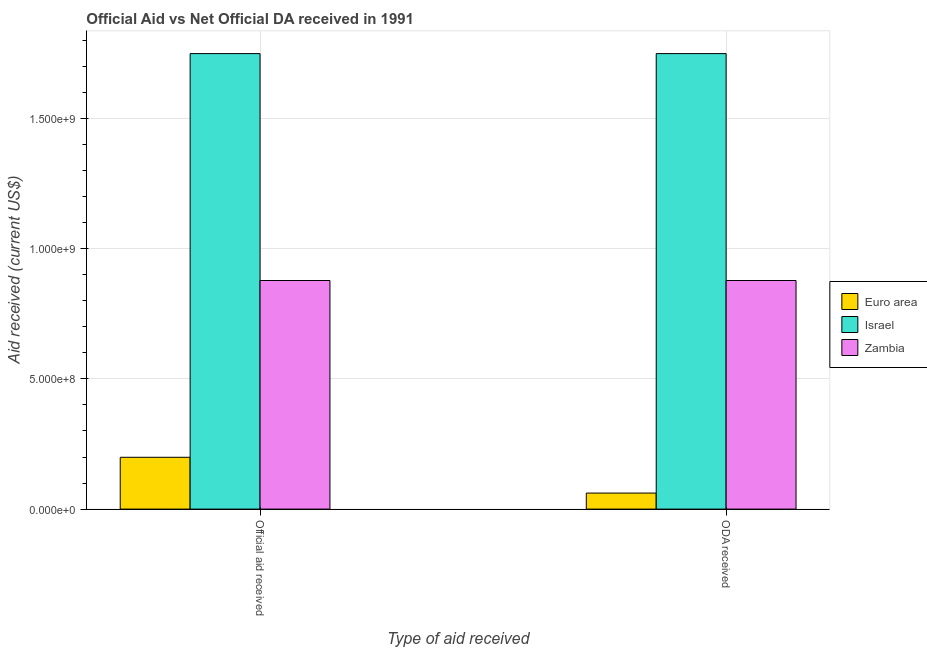How many different coloured bars are there?
Ensure brevity in your answer.  3. How many bars are there on the 1st tick from the right?
Make the answer very short. 3. What is the label of the 2nd group of bars from the left?
Provide a short and direct response. ODA received. What is the oda received in Euro area?
Offer a very short reply. 6.16e+07. Across all countries, what is the maximum official aid received?
Offer a terse response. 1.75e+09. Across all countries, what is the minimum official aid received?
Keep it short and to the point. 1.99e+08. In which country was the official aid received minimum?
Provide a short and direct response. Euro area. What is the total official aid received in the graph?
Keep it short and to the point. 2.83e+09. What is the difference between the official aid received in Euro area and that in Zambia?
Your response must be concise. -6.79e+08. What is the difference between the official aid received in Zambia and the oda received in Euro area?
Offer a very short reply. 8.16e+08. What is the average official aid received per country?
Your response must be concise. 9.42e+08. What is the ratio of the official aid received in Zambia to that in Israel?
Your response must be concise. 0.5. In how many countries, is the official aid received greater than the average official aid received taken over all countries?
Make the answer very short. 1. What does the 3rd bar from the left in ODA received represents?
Keep it short and to the point. Zambia. What does the 1st bar from the right in Official aid received represents?
Provide a succinct answer. Zambia. How many countries are there in the graph?
Your answer should be very brief. 3. Are the values on the major ticks of Y-axis written in scientific E-notation?
Ensure brevity in your answer.  Yes. Does the graph contain grids?
Give a very brief answer. Yes. How are the legend labels stacked?
Your answer should be compact. Vertical. What is the title of the graph?
Your answer should be compact. Official Aid vs Net Official DA received in 1991 . What is the label or title of the X-axis?
Keep it short and to the point. Type of aid received. What is the label or title of the Y-axis?
Offer a very short reply. Aid received (current US$). What is the Aid received (current US$) in Euro area in Official aid received?
Keep it short and to the point. 1.99e+08. What is the Aid received (current US$) in Israel in Official aid received?
Offer a very short reply. 1.75e+09. What is the Aid received (current US$) in Zambia in Official aid received?
Ensure brevity in your answer.  8.78e+08. What is the Aid received (current US$) of Euro area in ODA received?
Your answer should be very brief. 6.16e+07. What is the Aid received (current US$) in Israel in ODA received?
Provide a short and direct response. 1.75e+09. What is the Aid received (current US$) of Zambia in ODA received?
Your answer should be compact. 8.78e+08. Across all Type of aid received, what is the maximum Aid received (current US$) of Euro area?
Your answer should be very brief. 1.99e+08. Across all Type of aid received, what is the maximum Aid received (current US$) of Israel?
Make the answer very short. 1.75e+09. Across all Type of aid received, what is the maximum Aid received (current US$) in Zambia?
Your answer should be very brief. 8.78e+08. Across all Type of aid received, what is the minimum Aid received (current US$) in Euro area?
Your answer should be very brief. 6.16e+07. Across all Type of aid received, what is the minimum Aid received (current US$) of Israel?
Ensure brevity in your answer.  1.75e+09. Across all Type of aid received, what is the minimum Aid received (current US$) of Zambia?
Offer a very short reply. 8.78e+08. What is the total Aid received (current US$) in Euro area in the graph?
Keep it short and to the point. 2.61e+08. What is the total Aid received (current US$) in Israel in the graph?
Offer a terse response. 3.50e+09. What is the total Aid received (current US$) of Zambia in the graph?
Your answer should be very brief. 1.76e+09. What is the difference between the Aid received (current US$) in Euro area in Official aid received and that in ODA received?
Your answer should be compact. 1.37e+08. What is the difference between the Aid received (current US$) of Euro area in Official aid received and the Aid received (current US$) of Israel in ODA received?
Your answer should be very brief. -1.55e+09. What is the difference between the Aid received (current US$) of Euro area in Official aid received and the Aid received (current US$) of Zambia in ODA received?
Offer a terse response. -6.79e+08. What is the difference between the Aid received (current US$) of Israel in Official aid received and the Aid received (current US$) of Zambia in ODA received?
Ensure brevity in your answer.  8.71e+08. What is the average Aid received (current US$) of Euro area per Type of aid received?
Give a very brief answer. 1.30e+08. What is the average Aid received (current US$) in Israel per Type of aid received?
Your answer should be compact. 1.75e+09. What is the average Aid received (current US$) of Zambia per Type of aid received?
Make the answer very short. 8.78e+08. What is the difference between the Aid received (current US$) of Euro area and Aid received (current US$) of Israel in Official aid received?
Provide a short and direct response. -1.55e+09. What is the difference between the Aid received (current US$) of Euro area and Aid received (current US$) of Zambia in Official aid received?
Keep it short and to the point. -6.79e+08. What is the difference between the Aid received (current US$) of Israel and Aid received (current US$) of Zambia in Official aid received?
Provide a succinct answer. 8.71e+08. What is the difference between the Aid received (current US$) in Euro area and Aid received (current US$) in Israel in ODA received?
Make the answer very short. -1.69e+09. What is the difference between the Aid received (current US$) in Euro area and Aid received (current US$) in Zambia in ODA received?
Provide a succinct answer. -8.16e+08. What is the difference between the Aid received (current US$) in Israel and Aid received (current US$) in Zambia in ODA received?
Provide a succinct answer. 8.71e+08. What is the ratio of the Aid received (current US$) of Euro area in Official aid received to that in ODA received?
Ensure brevity in your answer.  3.23. What is the ratio of the Aid received (current US$) in Zambia in Official aid received to that in ODA received?
Your response must be concise. 1. What is the difference between the highest and the second highest Aid received (current US$) in Euro area?
Provide a succinct answer. 1.37e+08. What is the difference between the highest and the lowest Aid received (current US$) in Euro area?
Ensure brevity in your answer.  1.37e+08. 